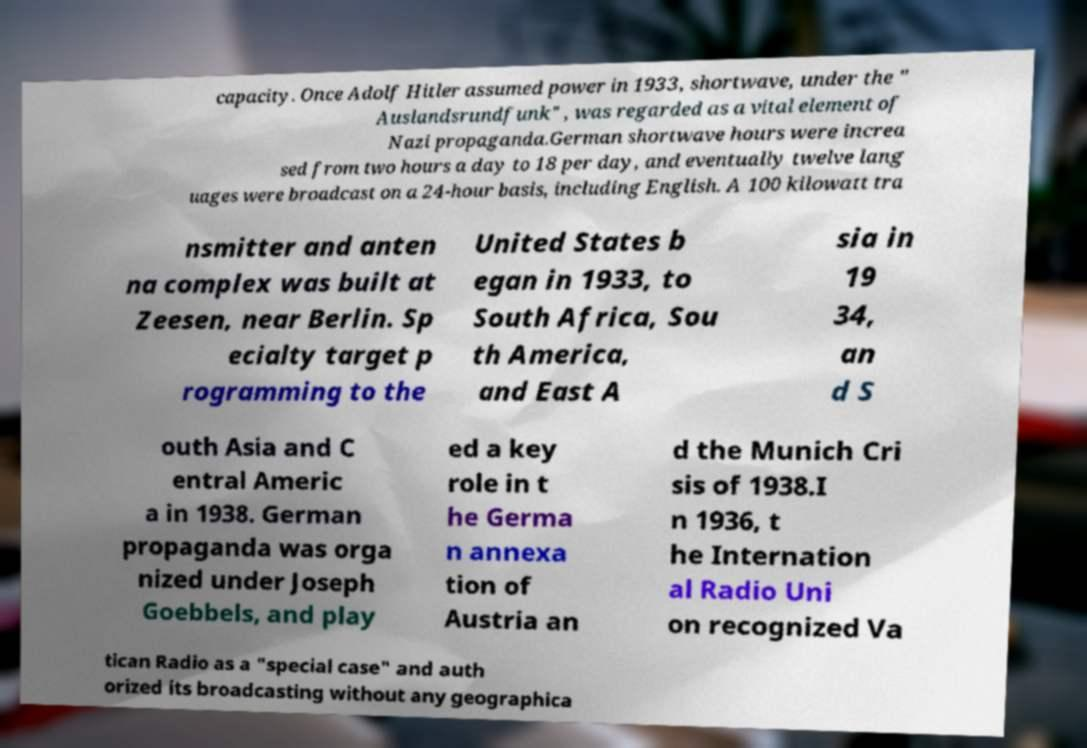What messages or text are displayed in this image? I need them in a readable, typed format. capacity. Once Adolf Hitler assumed power in 1933, shortwave, under the " Auslandsrundfunk" , was regarded as a vital element of Nazi propaganda.German shortwave hours were increa sed from two hours a day to 18 per day, and eventually twelve lang uages were broadcast on a 24-hour basis, including English. A 100 kilowatt tra nsmitter and anten na complex was built at Zeesen, near Berlin. Sp ecialty target p rogramming to the United States b egan in 1933, to South Africa, Sou th America, and East A sia in 19 34, an d S outh Asia and C entral Americ a in 1938. German propaganda was orga nized under Joseph Goebbels, and play ed a key role in t he Germa n annexa tion of Austria an d the Munich Cri sis of 1938.I n 1936, t he Internation al Radio Uni on recognized Va tican Radio as a "special case" and auth orized its broadcasting without any geographica 